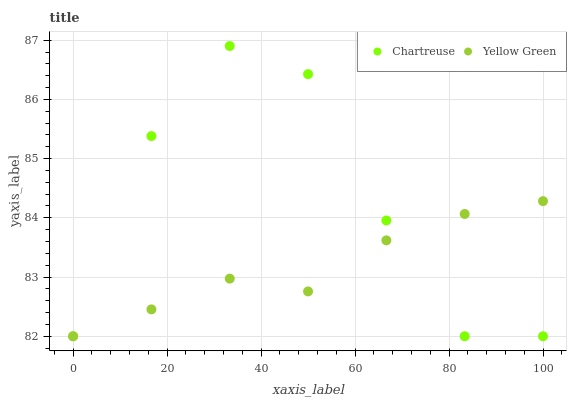Does Yellow Green have the minimum area under the curve?
Answer yes or no. Yes. Does Chartreuse have the maximum area under the curve?
Answer yes or no. Yes. Does Yellow Green have the maximum area under the curve?
Answer yes or no. No. Is Yellow Green the smoothest?
Answer yes or no. Yes. Is Chartreuse the roughest?
Answer yes or no. Yes. Is Yellow Green the roughest?
Answer yes or no. No. Does Chartreuse have the lowest value?
Answer yes or no. Yes. Does Chartreuse have the highest value?
Answer yes or no. Yes. Does Yellow Green have the highest value?
Answer yes or no. No. Does Yellow Green intersect Chartreuse?
Answer yes or no. Yes. Is Yellow Green less than Chartreuse?
Answer yes or no. No. Is Yellow Green greater than Chartreuse?
Answer yes or no. No. 